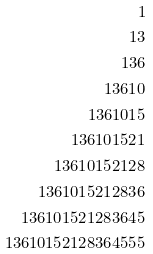<formula> <loc_0><loc_0><loc_500><loc_500>1 \\ 1 3 \\ 1 3 6 \\ 1 3 6 1 0 \\ 1 3 6 1 0 1 5 \\ 1 3 6 1 0 1 5 2 1 \\ 1 3 6 1 0 1 5 2 1 2 8 \\ 1 3 6 1 0 1 5 2 1 2 8 3 6 \\ 1 3 6 1 0 1 5 2 1 2 8 3 6 4 5 \\ 1 3 6 1 0 1 5 2 1 2 8 3 6 4 5 5 5</formula> 